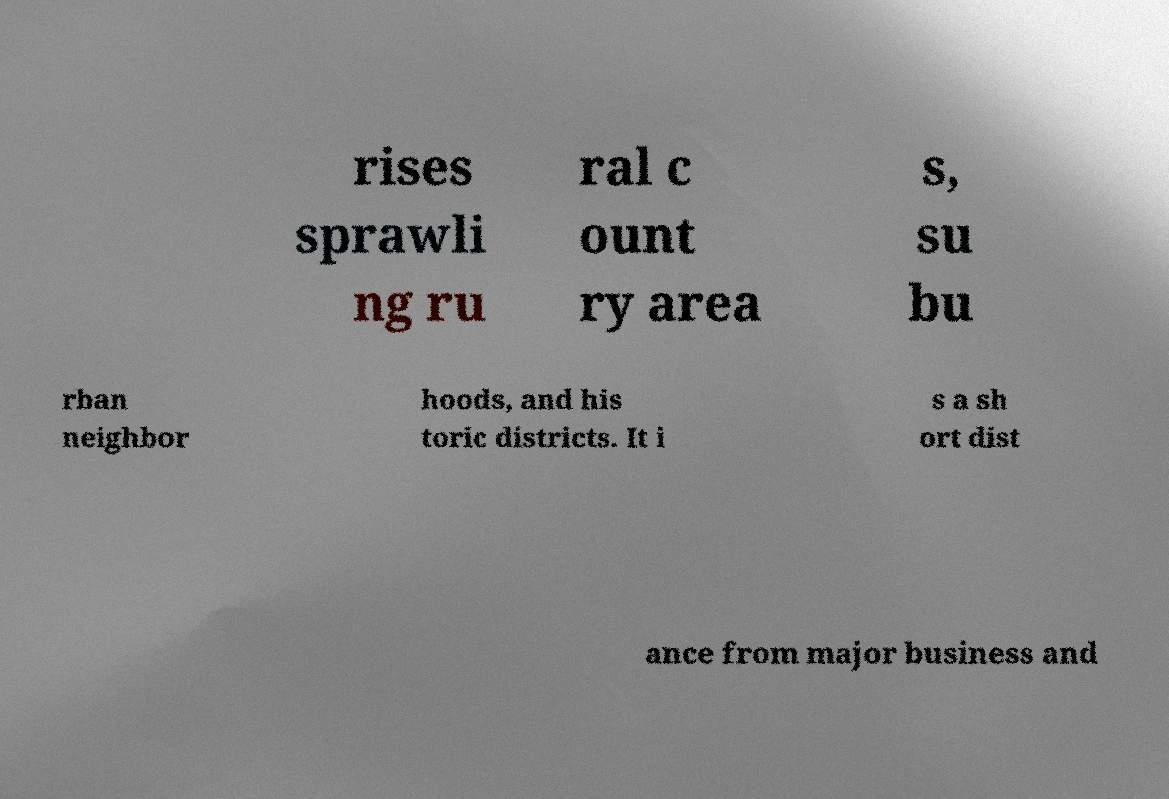What messages or text are displayed in this image? I need them in a readable, typed format. rises sprawli ng ru ral c ount ry area s, su bu rban neighbor hoods, and his toric districts. It i s a sh ort dist ance from major business and 